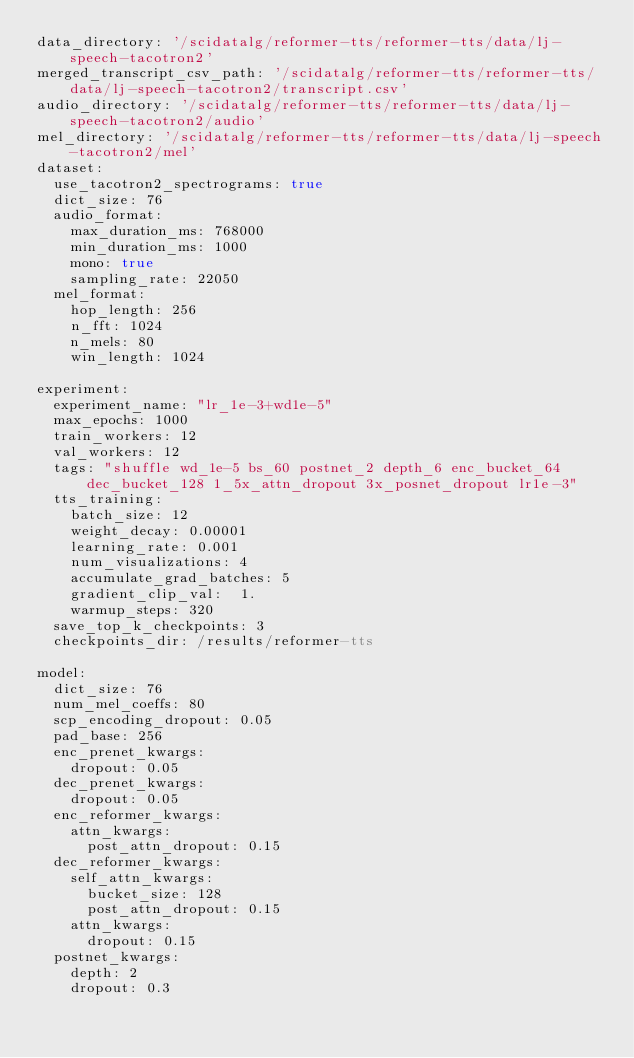<code> <loc_0><loc_0><loc_500><loc_500><_YAML_>data_directory: '/scidatalg/reformer-tts/reformer-tts/data/lj-speech-tacotron2'
merged_transcript_csv_path: '/scidatalg/reformer-tts/reformer-tts/data/lj-speech-tacotron2/transcript.csv'
audio_directory: '/scidatalg/reformer-tts/reformer-tts/data/lj-speech-tacotron2/audio'
mel_directory: '/scidatalg/reformer-tts/reformer-tts/data/lj-speech-tacotron2/mel'
dataset:
  use_tacotron2_spectrograms: true
  dict_size: 76
  audio_format:
    max_duration_ms: 768000
    min_duration_ms: 1000
    mono: true
    sampling_rate: 22050
  mel_format:
    hop_length: 256
    n_fft: 1024
    n_mels: 80
    win_length: 1024

experiment:
  experiment_name: "lr_1e-3+wd1e-5"
  max_epochs: 1000
  train_workers: 12
  val_workers: 12
  tags: "shuffle wd_1e-5 bs_60 postnet_2 depth_6 enc_bucket_64 dec_bucket_128 1_5x_attn_dropout 3x_posnet_dropout lr1e-3"
  tts_training:
    batch_size: 12
    weight_decay: 0.00001
    learning_rate: 0.001
    num_visualizations: 4
    accumulate_grad_batches: 5
    gradient_clip_val:  1.
    warmup_steps: 320
  save_top_k_checkpoints: 3
  checkpoints_dir: /results/reformer-tts

model:
  dict_size: 76
  num_mel_coeffs: 80
  scp_encoding_dropout: 0.05
  pad_base: 256
  enc_prenet_kwargs:
    dropout: 0.05
  dec_prenet_kwargs:
    dropout: 0.05
  enc_reformer_kwargs:
    attn_kwargs:
      post_attn_dropout: 0.15
  dec_reformer_kwargs:
    self_attn_kwargs:
      bucket_size: 128
      post_attn_dropout: 0.15
    attn_kwargs:
      dropout: 0.15
  postnet_kwargs:
    depth: 2
    dropout: 0.3
</code> 